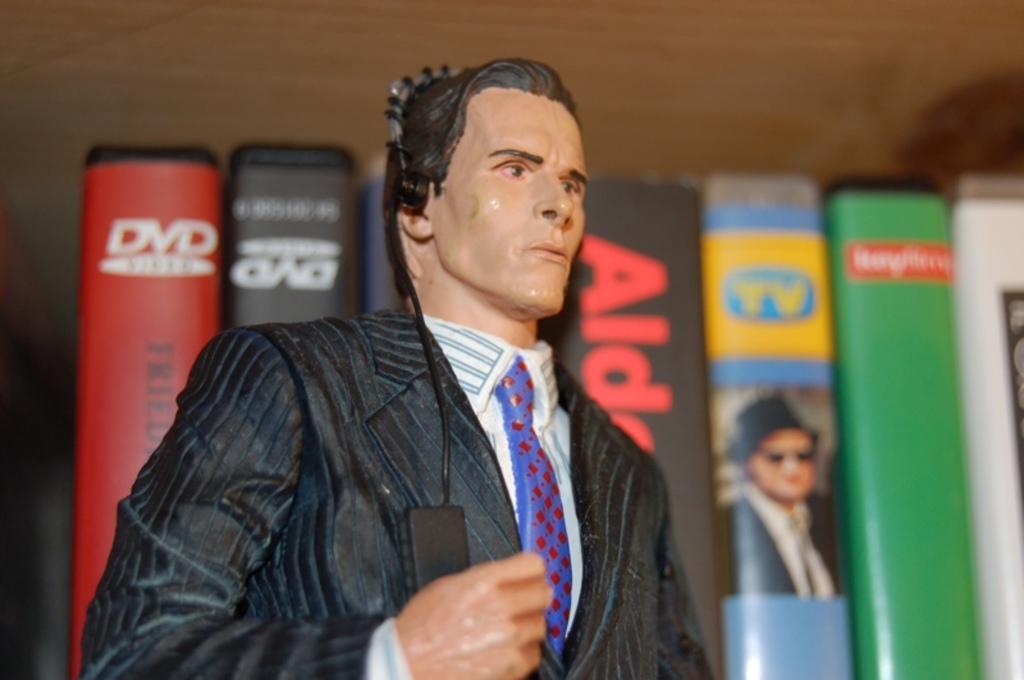Please provide a concise description of this image. In the image I can see a doll which is in the shape of a persona and also I can see books which are arranged. 